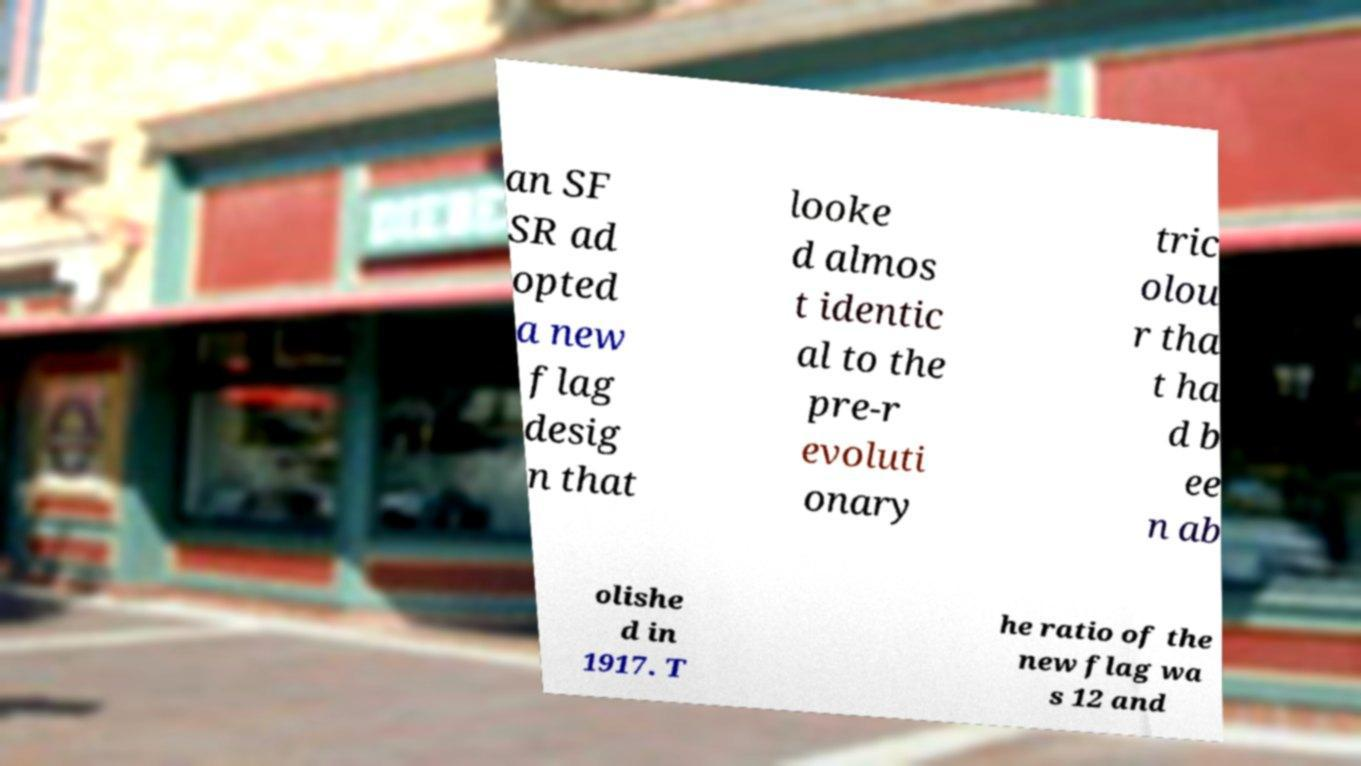There's text embedded in this image that I need extracted. Can you transcribe it verbatim? an SF SR ad opted a new flag desig n that looke d almos t identic al to the pre-r evoluti onary tric olou r tha t ha d b ee n ab olishe d in 1917. T he ratio of the new flag wa s 12 and 